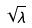<formula> <loc_0><loc_0><loc_500><loc_500>\sqrt { \lambda }</formula> 